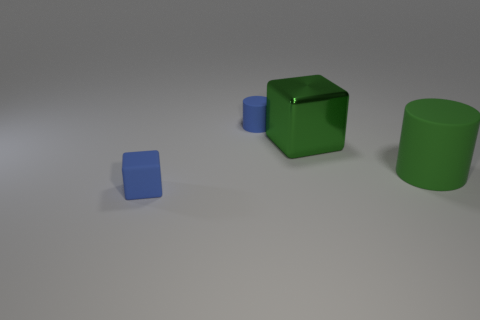Does the blue cylinder have the same material as the blue thing that is in front of the metal object?
Offer a very short reply. Yes. Is the number of tiny things that are behind the green cube the same as the number of tiny blue rubber objects that are behind the big cylinder?
Your response must be concise. Yes. What is the material of the big cylinder?
Your answer should be compact. Rubber. There is a object that is the same size as the blue block; what color is it?
Your answer should be compact. Blue. Is there a large matte thing that is on the left side of the tiny blue cylinder that is left of the metal block?
Your answer should be very brief. No. What number of blocks are big green metallic things or big matte objects?
Offer a terse response. 1. What is the size of the blue rubber object that is behind the tiny matte thing to the left of the tiny object that is behind the large green matte thing?
Ensure brevity in your answer.  Small. There is a green rubber thing; are there any small blue blocks to the right of it?
Keep it short and to the point. No. The matte object that is the same color as the big metallic object is what shape?
Your answer should be compact. Cylinder. How many things are either big things behind the green matte object or small yellow blocks?
Offer a terse response. 1. 